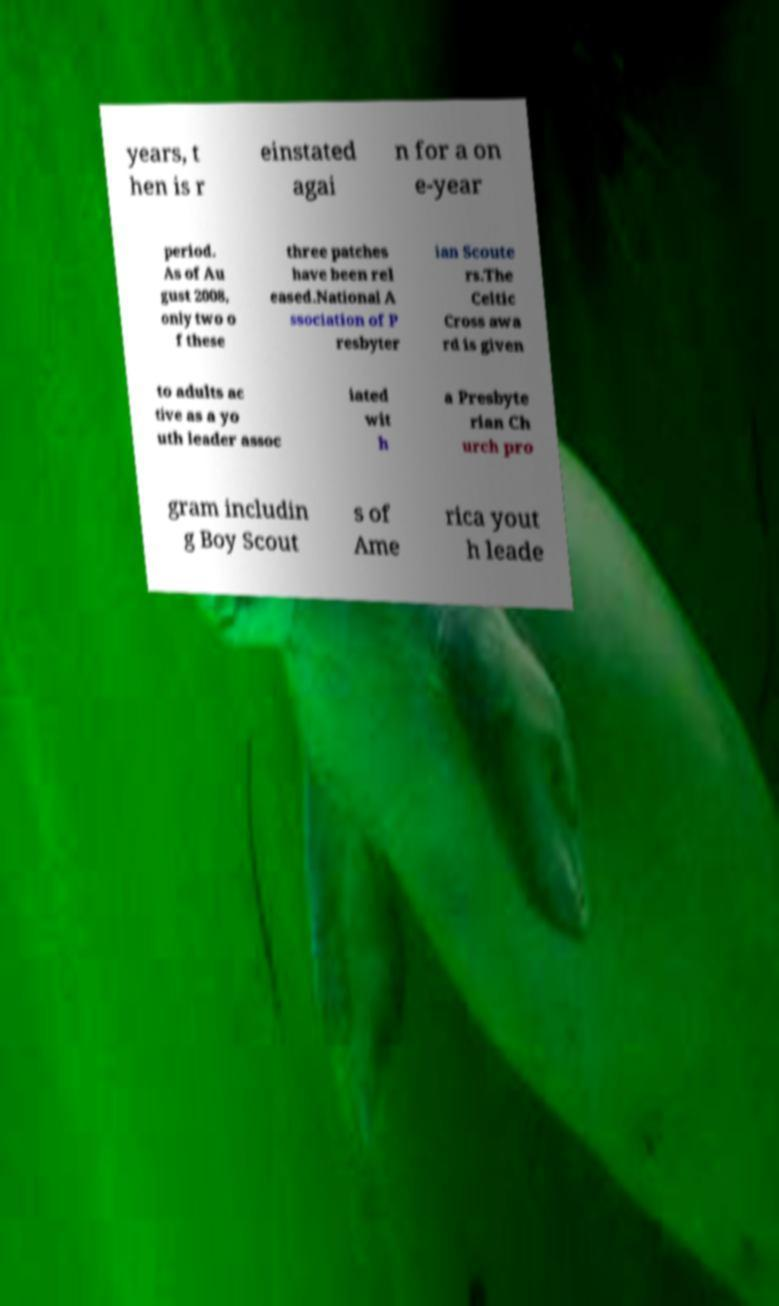Please read and relay the text visible in this image. What does it say? years, t hen is r einstated agai n for a on e-year period. As of Au gust 2008, only two o f these three patches have been rel eased.National A ssociation of P resbyter ian Scoute rs.The Celtic Cross awa rd is given to adults ac tive as a yo uth leader assoc iated wit h a Presbyte rian Ch urch pro gram includin g Boy Scout s of Ame rica yout h leade 